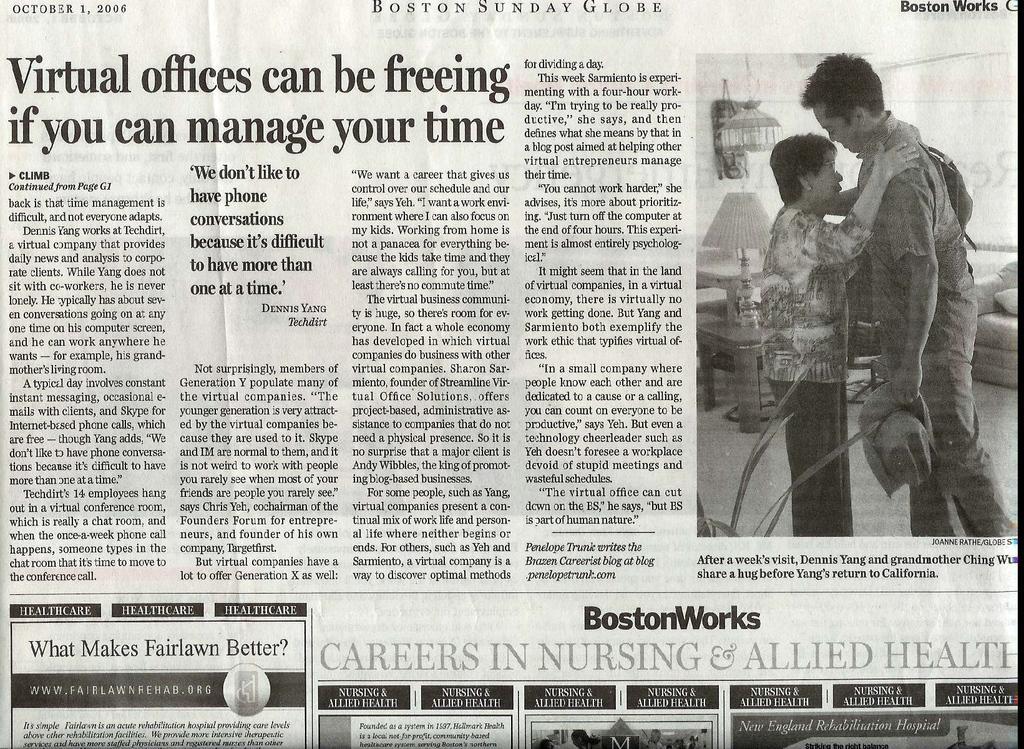How would you summarize this image in a sentence or two? This is a newspaper and in this paper we can see a man and a woman standing on the floor, lamp, sofa and some text. 